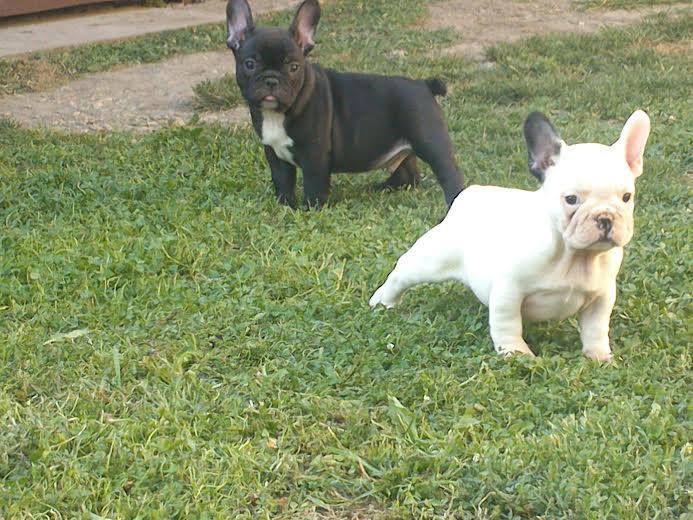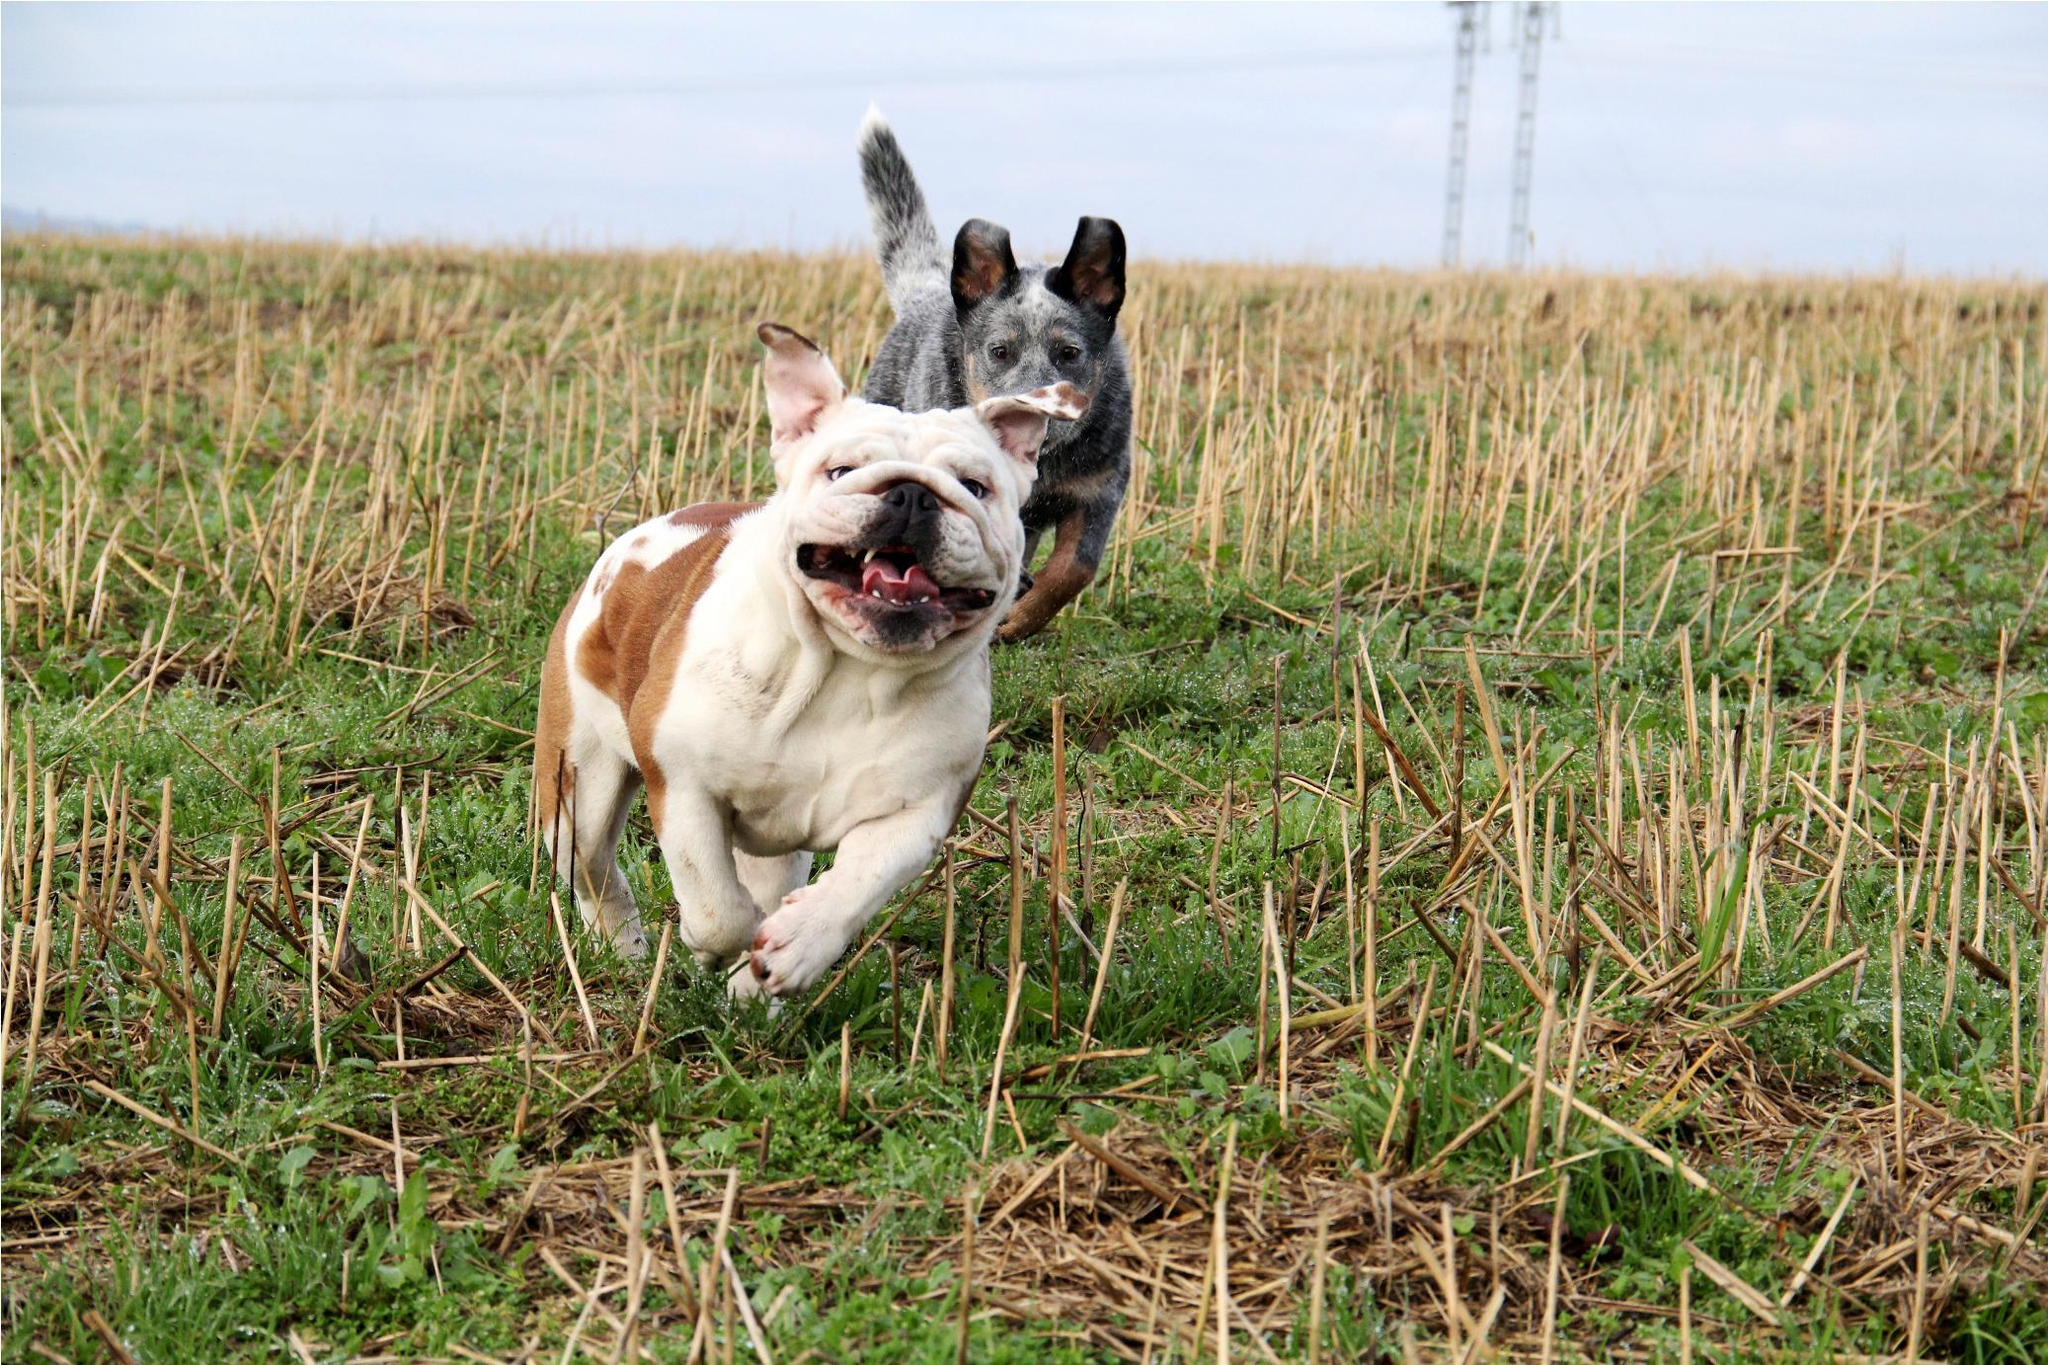The first image is the image on the left, the second image is the image on the right. Assess this claim about the two images: "The right image shows a black and white french bulldog puppy running on sand". Correct or not? Answer yes or no. No. The first image is the image on the left, the second image is the image on the right. Evaluate the accuracy of this statement regarding the images: "A single white and black dog is running in the sand.". Is it true? Answer yes or no. No. 